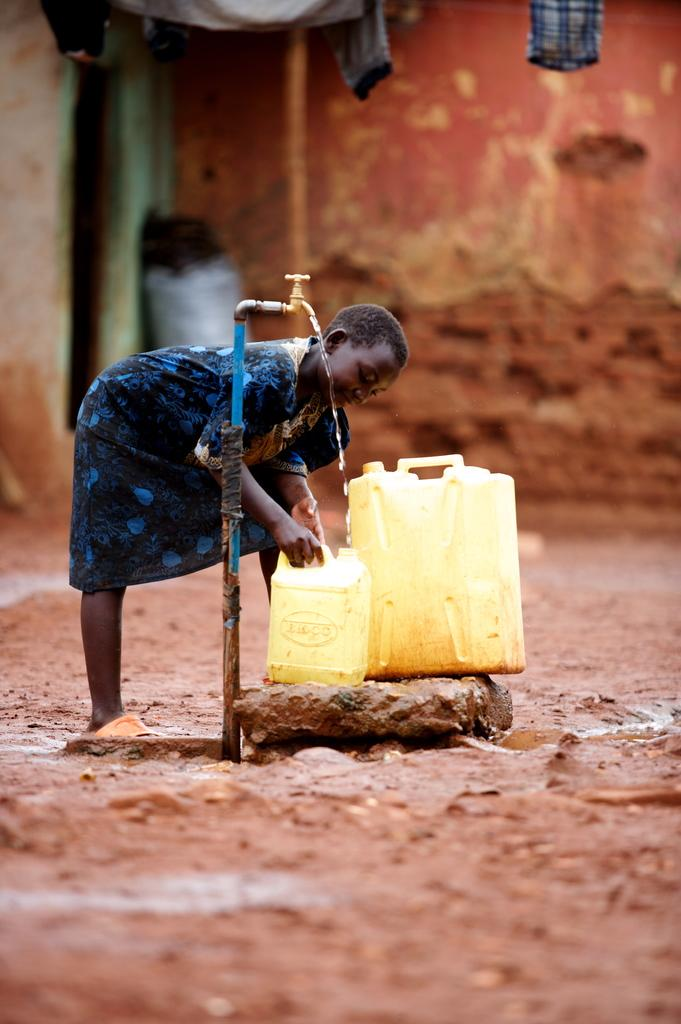Who is present in the image? There is a woman in the image. What is the woman's position in relation to the land? The woman is standing on the land. What object is present in the image that is related to water? There is a tap in the image. What are the water cans used for in the image? The water cans are present in the image for collecting water. What can be seen in the background of the image? There is a wall in the background of the image. Is the woman sleeping on the seashore in the image? No, the woman is standing on the land, and there is no seashore present in the image. 